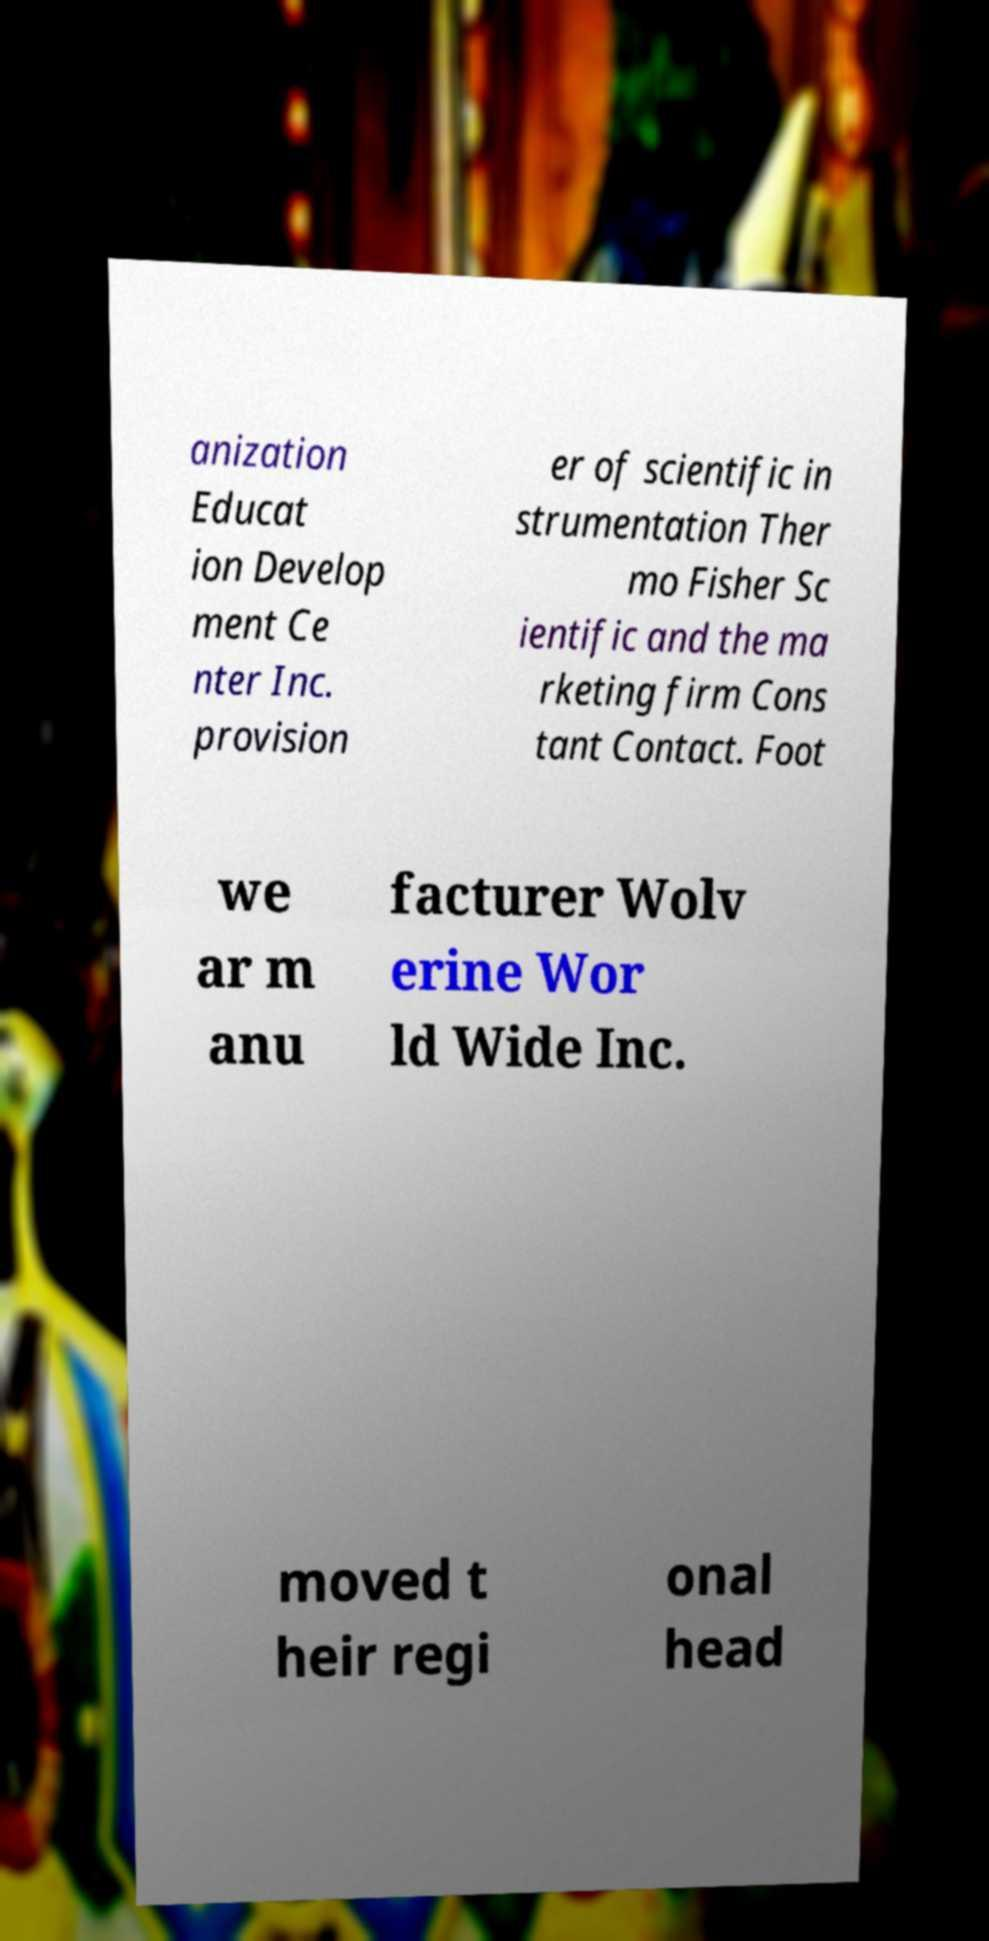Please read and relay the text visible in this image. What does it say? anization Educat ion Develop ment Ce nter Inc. provision er of scientific in strumentation Ther mo Fisher Sc ientific and the ma rketing firm Cons tant Contact. Foot we ar m anu facturer Wolv erine Wor ld Wide Inc. moved t heir regi onal head 